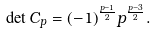<formula> <loc_0><loc_0><loc_500><loc_500>\det { C } _ { p } = ( - 1 ) ^ { \frac { p - 1 } { 2 } } p ^ { \frac { p - 3 } { 2 } } .</formula> 